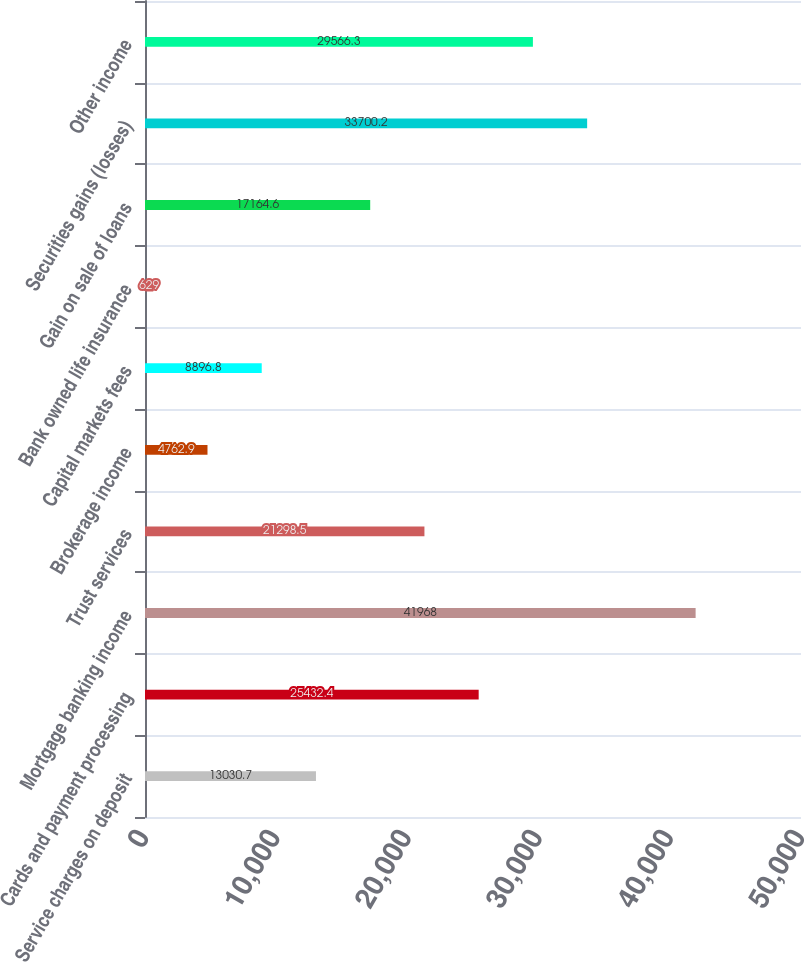Convert chart to OTSL. <chart><loc_0><loc_0><loc_500><loc_500><bar_chart><fcel>Service charges on deposit<fcel>Cards and payment processing<fcel>Mortgage banking income<fcel>Trust services<fcel>Brokerage income<fcel>Capital markets fees<fcel>Bank owned life insurance<fcel>Gain on sale of loans<fcel>Securities gains (losses)<fcel>Other income<nl><fcel>13030.7<fcel>25432.4<fcel>41968<fcel>21298.5<fcel>4762.9<fcel>8896.8<fcel>629<fcel>17164.6<fcel>33700.2<fcel>29566.3<nl></chart> 